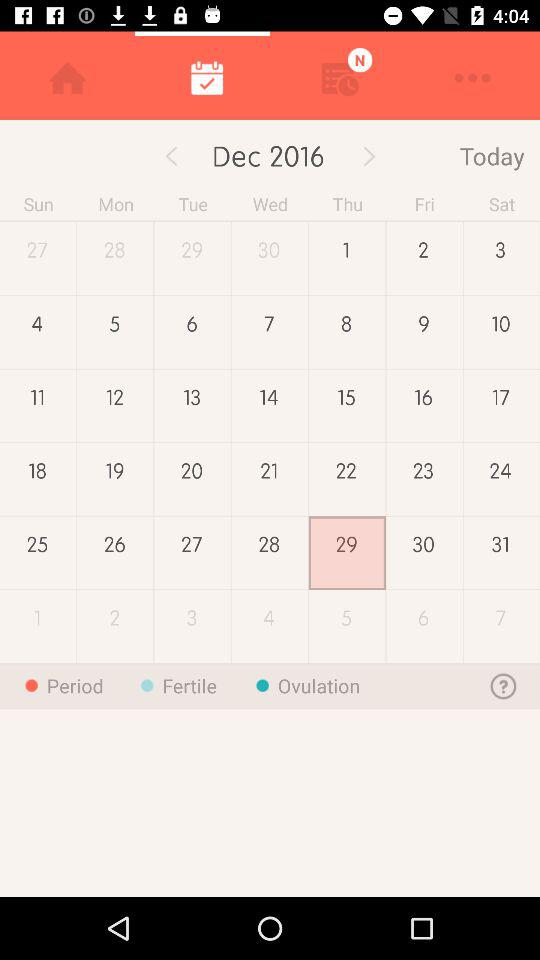What is the day today? The day is Thursday. 